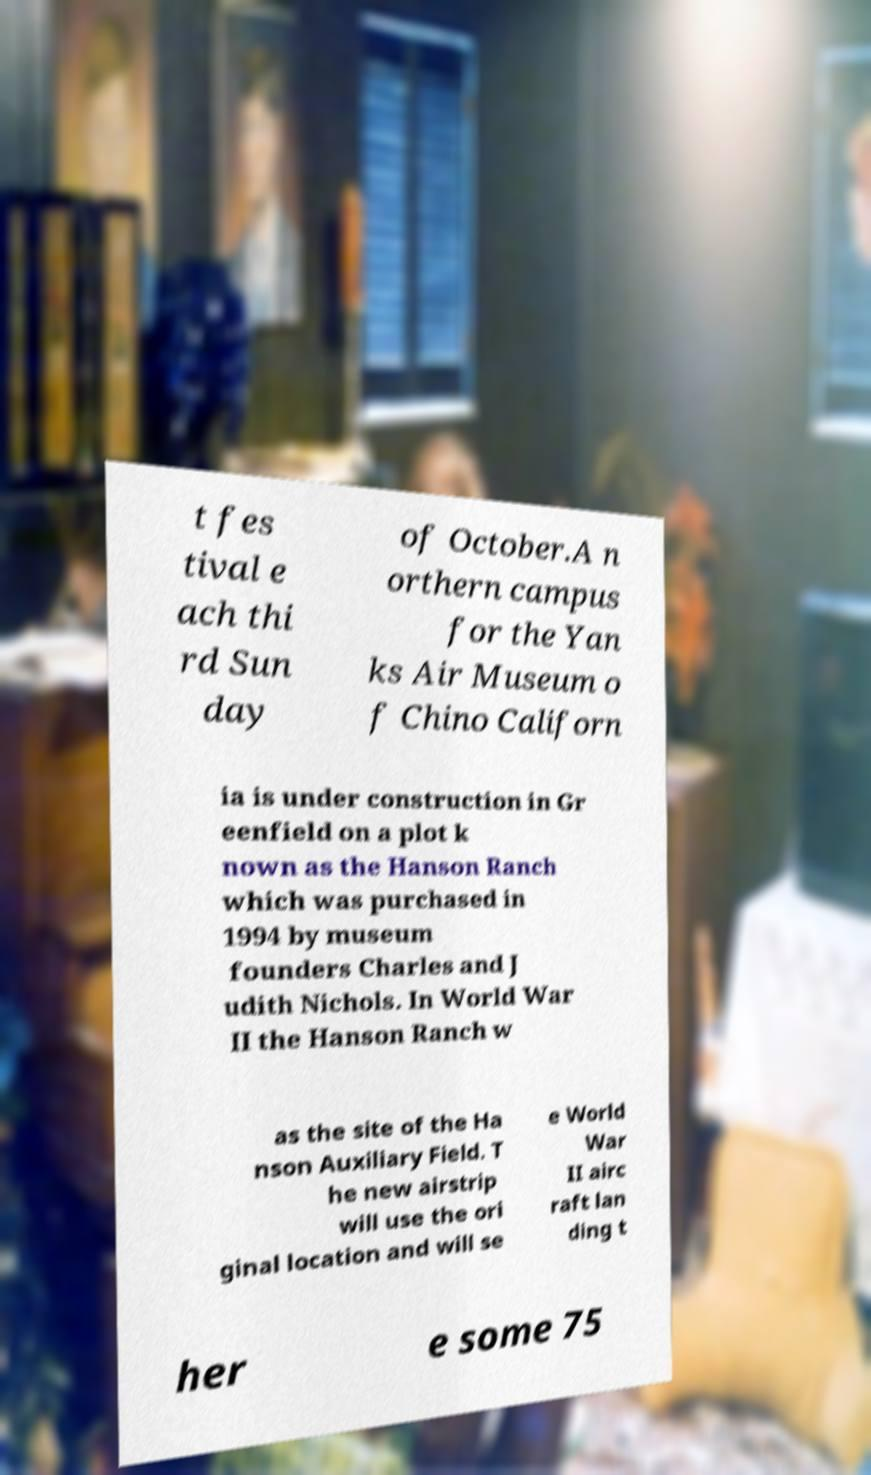Could you extract and type out the text from this image? t fes tival e ach thi rd Sun day of October.A n orthern campus for the Yan ks Air Museum o f Chino Californ ia is under construction in Gr eenfield on a plot k nown as the Hanson Ranch which was purchased in 1994 by museum founders Charles and J udith Nichols. In World War II the Hanson Ranch w as the site of the Ha nson Auxiliary Field. T he new airstrip will use the ori ginal location and will se e World War II airc raft lan ding t her e some 75 